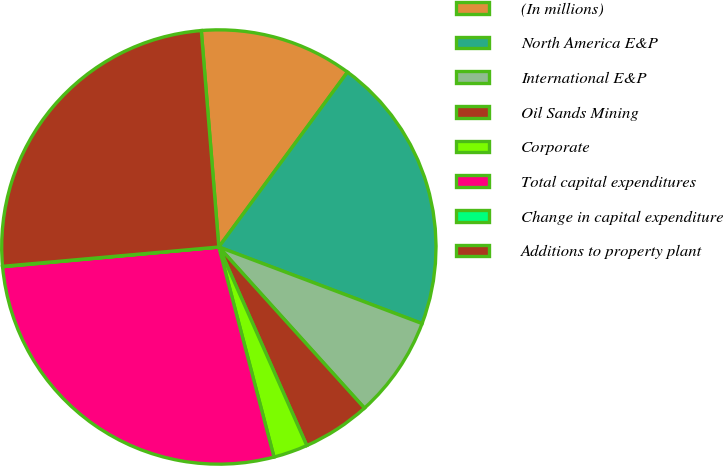Convert chart. <chart><loc_0><loc_0><loc_500><loc_500><pie_chart><fcel>(In millions)<fcel>North America E&P<fcel>International E&P<fcel>Oil Sands Mining<fcel>Corporate<fcel>Total capital expenditures<fcel>Change in capital expenditure<fcel>Additions to property plant<nl><fcel>11.38%<fcel>20.64%<fcel>7.57%<fcel>5.06%<fcel>2.55%<fcel>27.64%<fcel>0.03%<fcel>25.13%<nl></chart> 